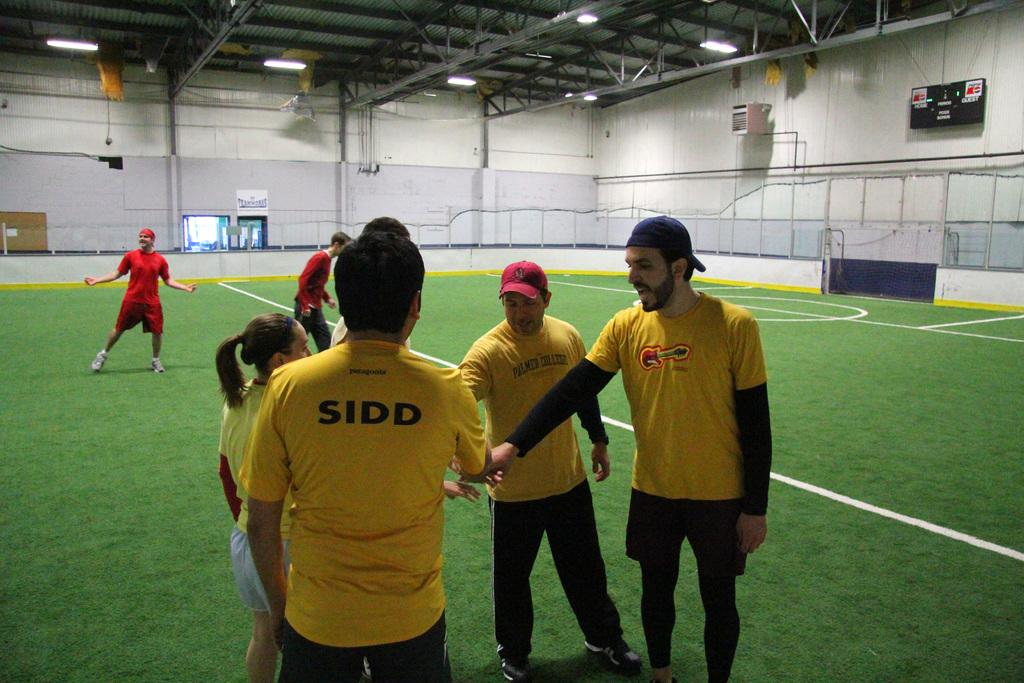<image>
Summarize the visual content of the image. A group of athletes prepare to practice soccer with their friend Sidd. 